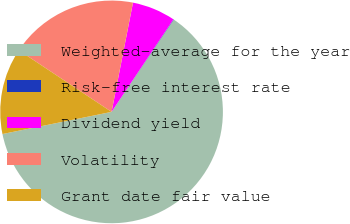<chart> <loc_0><loc_0><loc_500><loc_500><pie_chart><fcel>Weighted-average for the year<fcel>Risk-free interest rate<fcel>Dividend yield<fcel>Volatility<fcel>Grant date fair value<nl><fcel>62.37%<fcel>0.06%<fcel>6.29%<fcel>18.75%<fcel>12.52%<nl></chart> 